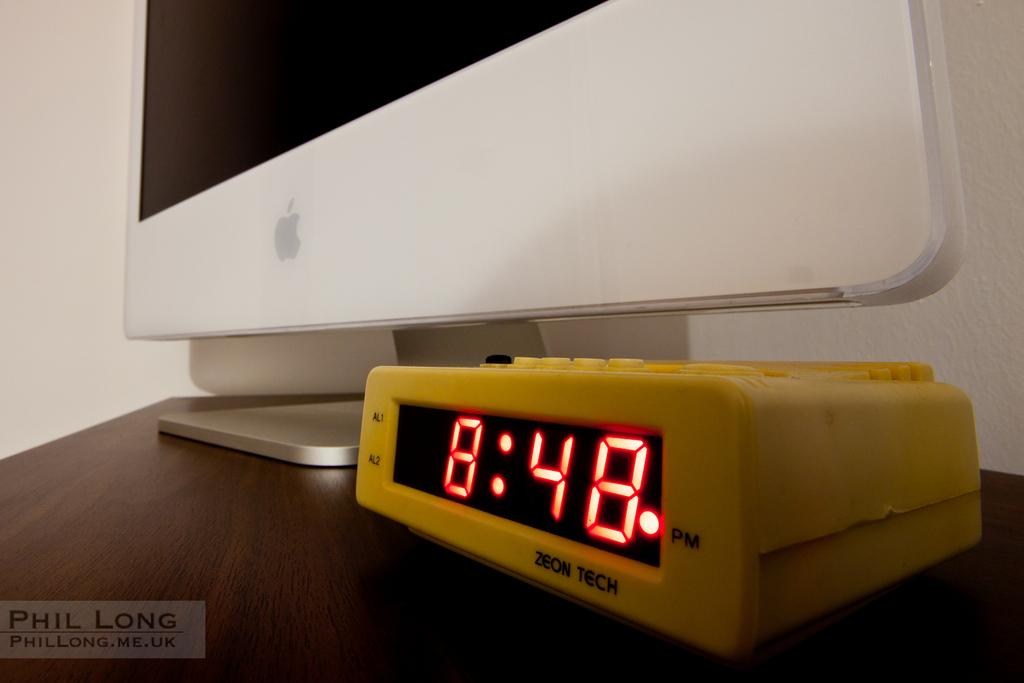<image>
Describe the image concisely. A yellow Zeon Tech Alarm clock displaying the time of 8:48 